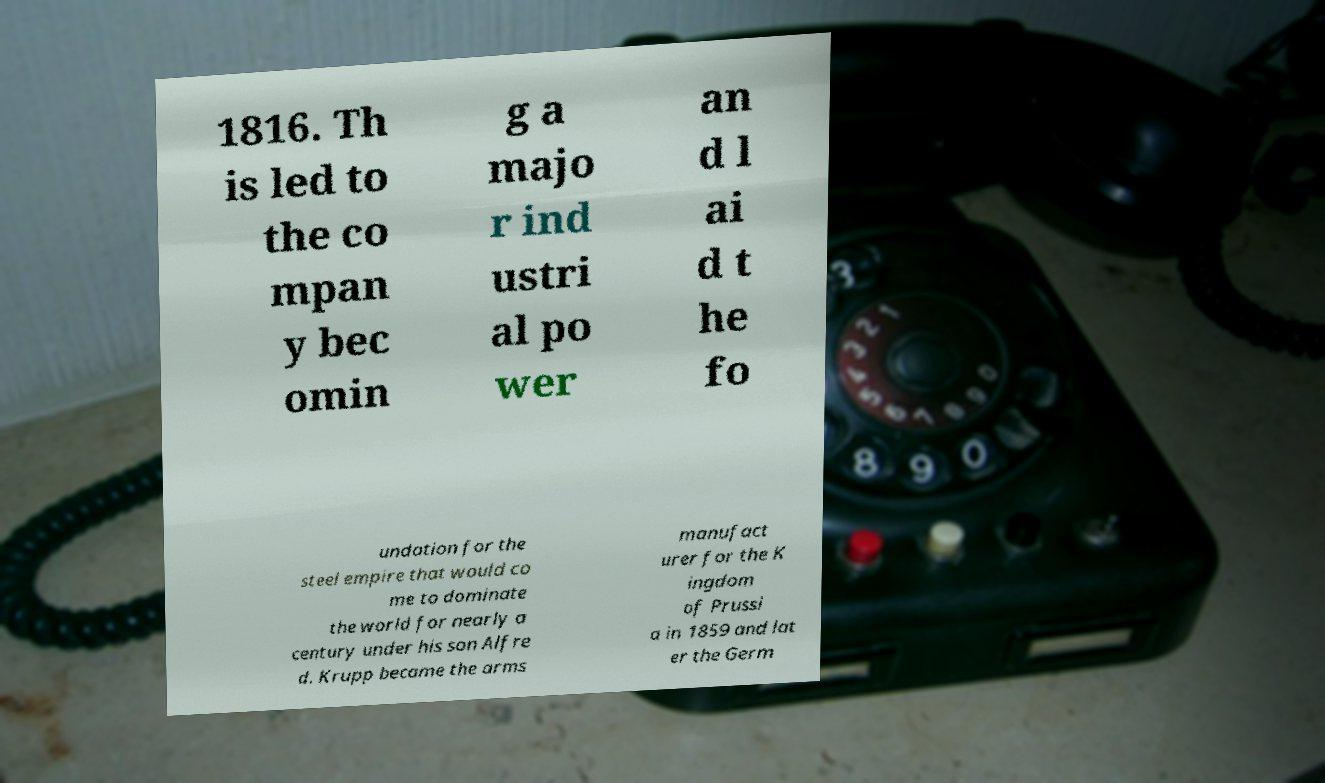Could you extract and type out the text from this image? 1816. Th is led to the co mpan y bec omin g a majo r ind ustri al po wer an d l ai d t he fo undation for the steel empire that would co me to dominate the world for nearly a century under his son Alfre d. Krupp became the arms manufact urer for the K ingdom of Prussi a in 1859 and lat er the Germ 